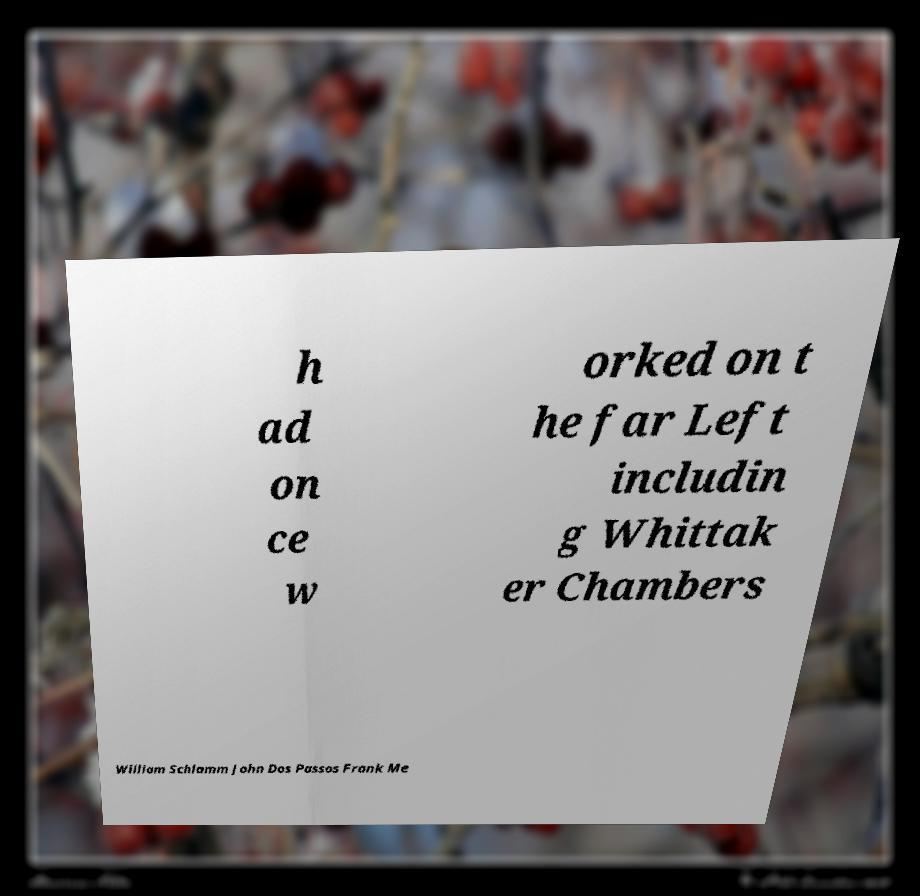There's text embedded in this image that I need extracted. Can you transcribe it verbatim? h ad on ce w orked on t he far Left includin g Whittak er Chambers William Schlamm John Dos Passos Frank Me 